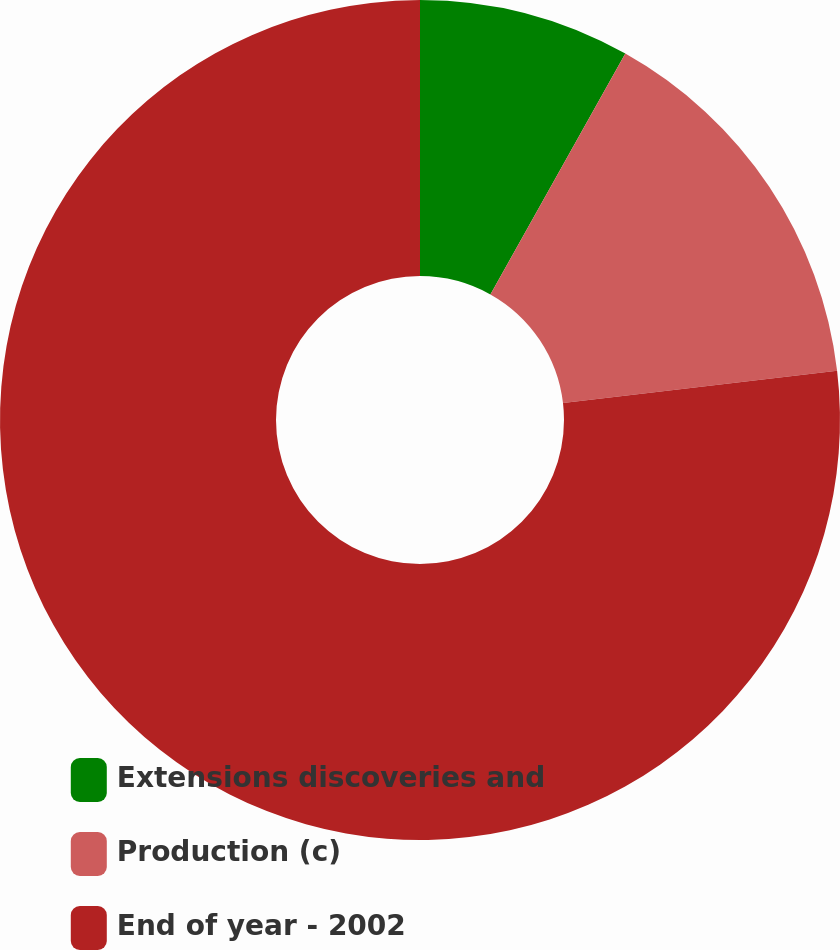<chart> <loc_0><loc_0><loc_500><loc_500><pie_chart><fcel>Extensions discoveries and<fcel>Production (c)<fcel>End of year - 2002<nl><fcel>8.13%<fcel>15.0%<fcel>76.87%<nl></chart> 